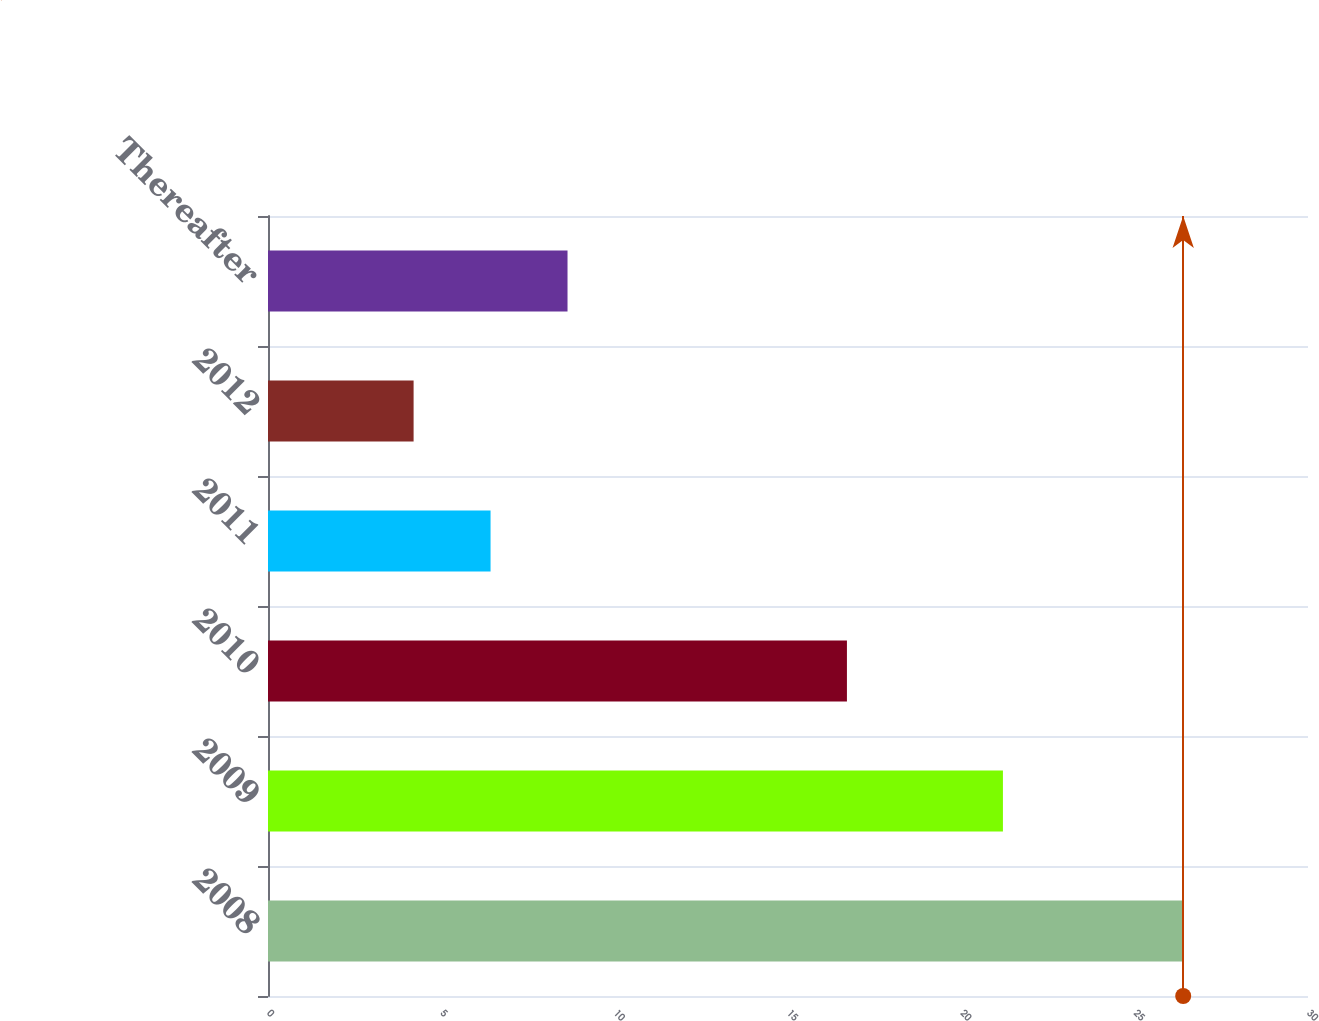Convert chart to OTSL. <chart><loc_0><loc_0><loc_500><loc_500><bar_chart><fcel>2008<fcel>2009<fcel>2010<fcel>2011<fcel>2012<fcel>Thereafter<nl><fcel>26.4<fcel>21.2<fcel>16.7<fcel>6.42<fcel>4.2<fcel>8.64<nl></chart> 